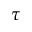Convert formula to latex. <formula><loc_0><loc_0><loc_500><loc_500>\tau</formula> 